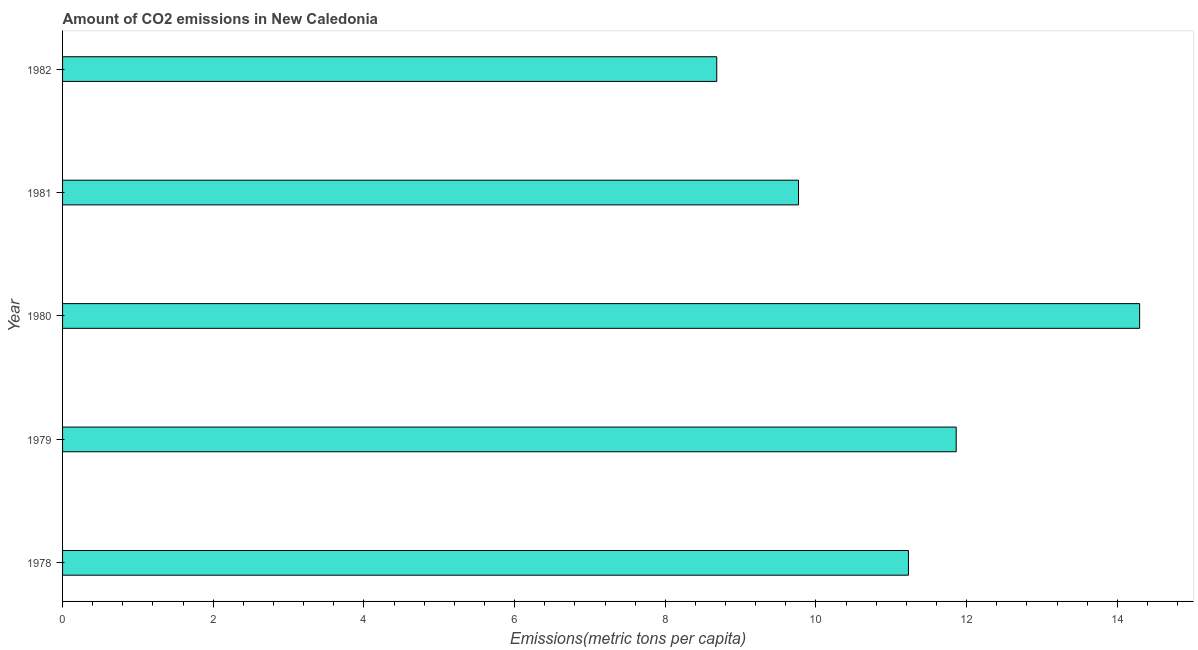Does the graph contain any zero values?
Make the answer very short. No. What is the title of the graph?
Ensure brevity in your answer.  Amount of CO2 emissions in New Caledonia. What is the label or title of the X-axis?
Provide a short and direct response. Emissions(metric tons per capita). What is the amount of co2 emissions in 1981?
Keep it short and to the point. 9.77. Across all years, what is the maximum amount of co2 emissions?
Provide a succinct answer. 14.3. Across all years, what is the minimum amount of co2 emissions?
Give a very brief answer. 8.68. In which year was the amount of co2 emissions maximum?
Offer a terse response. 1980. In which year was the amount of co2 emissions minimum?
Provide a succinct answer. 1982. What is the sum of the amount of co2 emissions?
Provide a short and direct response. 55.84. What is the difference between the amount of co2 emissions in 1980 and 1981?
Provide a short and direct response. 4.53. What is the average amount of co2 emissions per year?
Provide a short and direct response. 11.17. What is the median amount of co2 emissions?
Provide a short and direct response. 11.23. In how many years, is the amount of co2 emissions greater than 2.4 metric tons per capita?
Provide a short and direct response. 5. What is the ratio of the amount of co2 emissions in 1980 to that in 1981?
Keep it short and to the point. 1.46. Is the amount of co2 emissions in 1978 less than that in 1979?
Provide a short and direct response. Yes. Is the difference between the amount of co2 emissions in 1979 and 1980 greater than the difference between any two years?
Provide a short and direct response. No. What is the difference between the highest and the second highest amount of co2 emissions?
Your answer should be compact. 2.44. What is the difference between the highest and the lowest amount of co2 emissions?
Your answer should be very brief. 5.61. How many bars are there?
Ensure brevity in your answer.  5. Are all the bars in the graph horizontal?
Your response must be concise. Yes. What is the Emissions(metric tons per capita) of 1978?
Ensure brevity in your answer.  11.23. What is the Emissions(metric tons per capita) of 1979?
Your response must be concise. 11.86. What is the Emissions(metric tons per capita) of 1980?
Provide a succinct answer. 14.3. What is the Emissions(metric tons per capita) in 1981?
Provide a short and direct response. 9.77. What is the Emissions(metric tons per capita) in 1982?
Keep it short and to the point. 8.68. What is the difference between the Emissions(metric tons per capita) in 1978 and 1979?
Keep it short and to the point. -0.63. What is the difference between the Emissions(metric tons per capita) in 1978 and 1980?
Your response must be concise. -3.07. What is the difference between the Emissions(metric tons per capita) in 1978 and 1981?
Your answer should be very brief. 1.46. What is the difference between the Emissions(metric tons per capita) in 1978 and 1982?
Your answer should be very brief. 2.54. What is the difference between the Emissions(metric tons per capita) in 1979 and 1980?
Your response must be concise. -2.43. What is the difference between the Emissions(metric tons per capita) in 1979 and 1981?
Your answer should be compact. 2.09. What is the difference between the Emissions(metric tons per capita) in 1979 and 1982?
Give a very brief answer. 3.18. What is the difference between the Emissions(metric tons per capita) in 1980 and 1981?
Keep it short and to the point. 4.53. What is the difference between the Emissions(metric tons per capita) in 1980 and 1982?
Your response must be concise. 5.61. What is the difference between the Emissions(metric tons per capita) in 1981 and 1982?
Your answer should be very brief. 1.09. What is the ratio of the Emissions(metric tons per capita) in 1978 to that in 1979?
Your answer should be compact. 0.95. What is the ratio of the Emissions(metric tons per capita) in 1978 to that in 1980?
Provide a short and direct response. 0.79. What is the ratio of the Emissions(metric tons per capita) in 1978 to that in 1981?
Give a very brief answer. 1.15. What is the ratio of the Emissions(metric tons per capita) in 1978 to that in 1982?
Provide a succinct answer. 1.29. What is the ratio of the Emissions(metric tons per capita) in 1979 to that in 1980?
Your response must be concise. 0.83. What is the ratio of the Emissions(metric tons per capita) in 1979 to that in 1981?
Provide a succinct answer. 1.21. What is the ratio of the Emissions(metric tons per capita) in 1979 to that in 1982?
Your answer should be very brief. 1.37. What is the ratio of the Emissions(metric tons per capita) in 1980 to that in 1981?
Your answer should be very brief. 1.46. What is the ratio of the Emissions(metric tons per capita) in 1980 to that in 1982?
Ensure brevity in your answer.  1.65. What is the ratio of the Emissions(metric tons per capita) in 1981 to that in 1982?
Offer a very short reply. 1.12. 